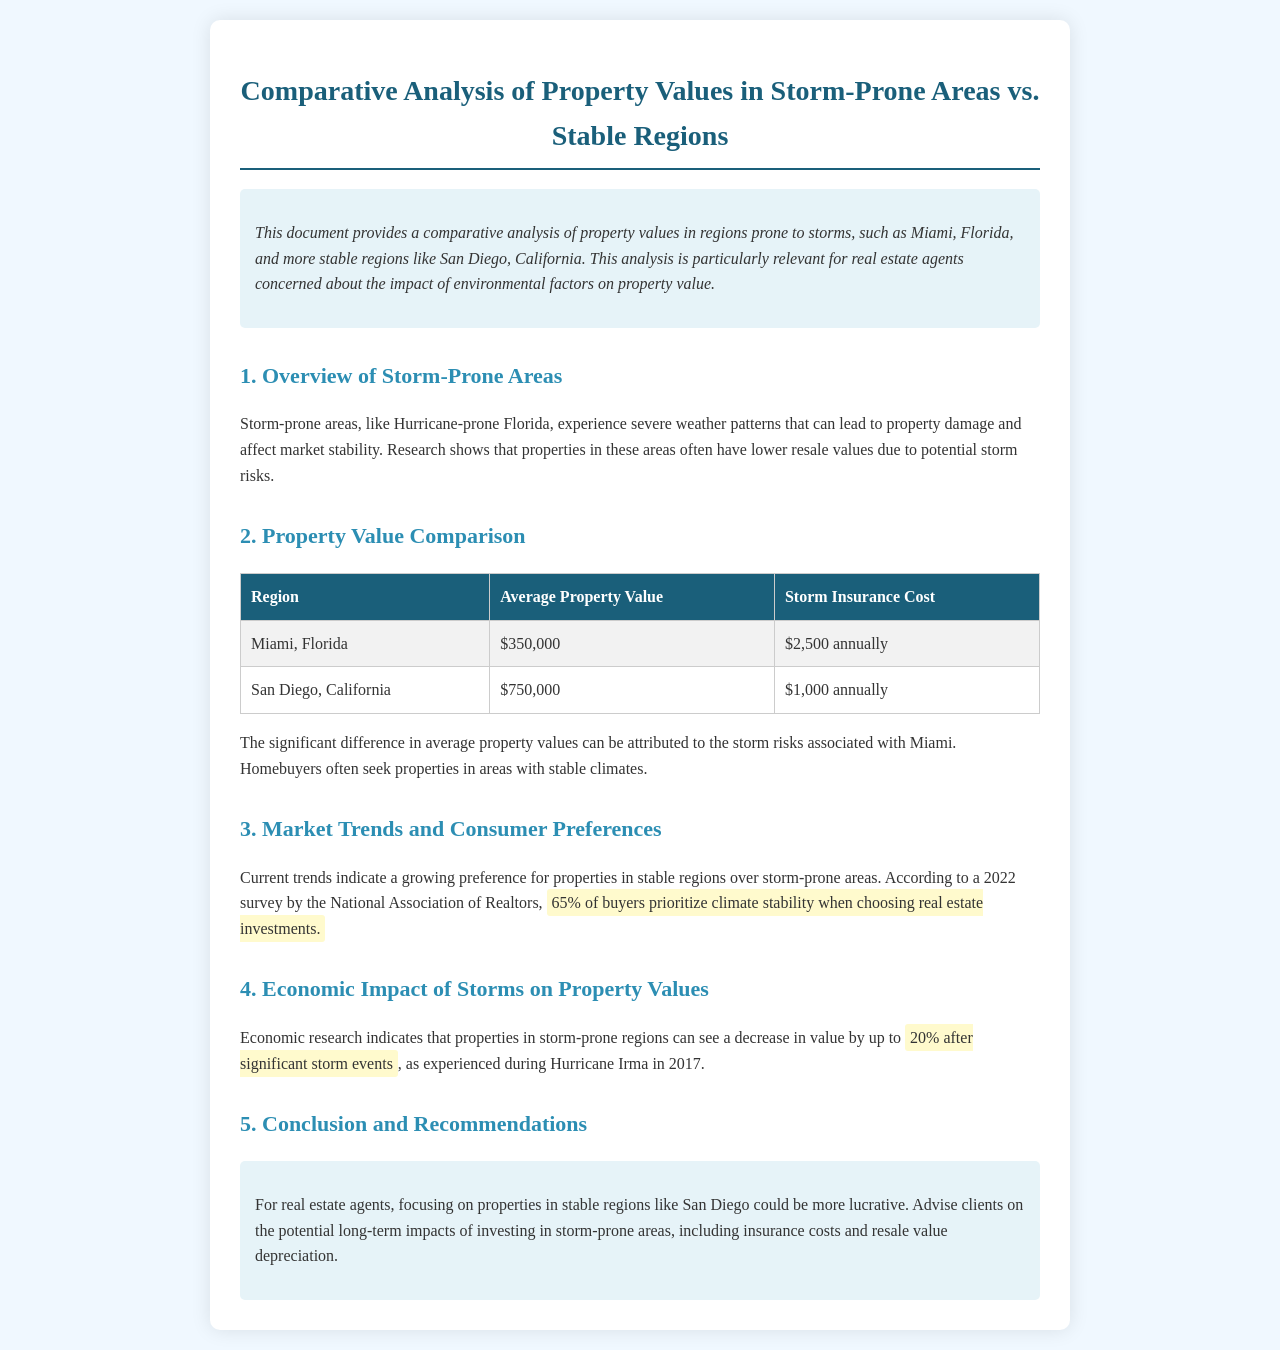what is the average property value in Miami? The average property value in Miami, Florida is provided in the table.
Answer: $350,000 what is the storm insurance cost for San Diego? The storm insurance cost for San Diego is listed in the property value comparison table.
Answer: $1,000 annually which area shows a greater average property value? The property value comparison indicates a clear difference between the two regions.
Answer: San Diego what percentage of buyers prioritize climate stability? The document cites a specific percentage regarding buyer preferences based on a survey.
Answer: 65% by what percentage can property values decrease after significant storm events? The document explains the economic impact of storms on property values with a specific percentage.
Answer: 20% what is one recommendation for real estate agents? The conclusion section provides advice for real estate agents regarding property investments.
Answer: Focus on stable regions name one storm-prone area mentioned. The introduction outlines specific storm-prone areas relevant to the analysis.
Answer: Miami name one stable region mentioned. The document contrasts stable regions with storm-prone areas in the analysis.
Answer: San Diego 